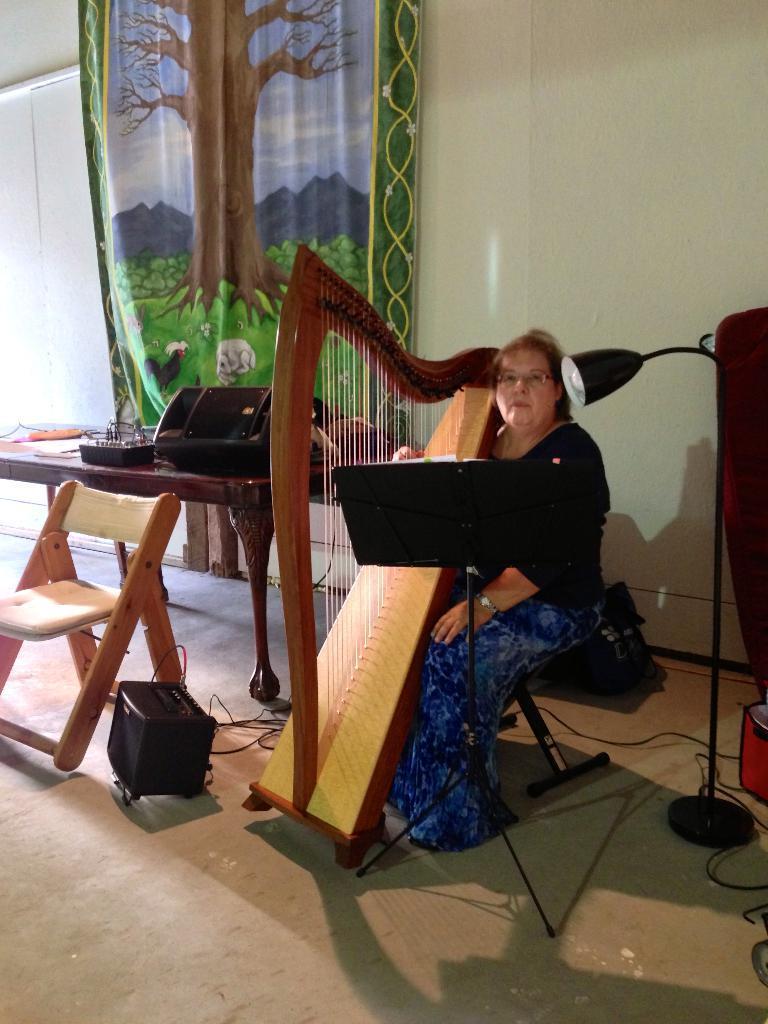Describe this image in one or two sentences. In this picture we can see a woman is sitting on a chair and holding a harp, there is a music stand in front of her, on the right side we can see a lamp and a wall, on the left side we can see a table and a chair, there are some things present on the table, there is a speaker at the bottom, in the background we can see a cloth, there is a picture of a tree on the cloth. 